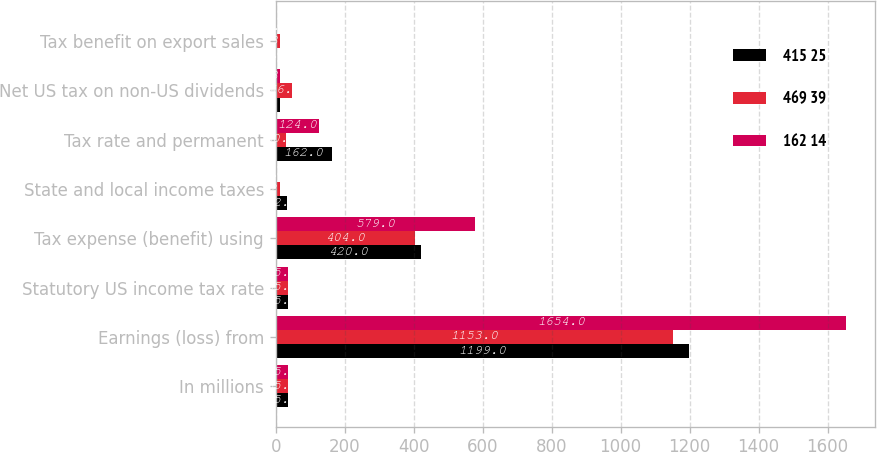Convert chart. <chart><loc_0><loc_0><loc_500><loc_500><stacked_bar_chart><ecel><fcel>In millions<fcel>Earnings (loss) from<fcel>Statutory US income tax rate<fcel>Tax expense (benefit) using<fcel>State and local income taxes<fcel>Tax rate and permanent<fcel>Net US tax on non-US dividends<fcel>Tax benefit on export sales<nl><fcel>415 25<fcel>35<fcel>1199<fcel>35<fcel>420<fcel>32<fcel>162<fcel>11<fcel>2<nl><fcel>469 39<fcel>35<fcel>1153<fcel>35<fcel>404<fcel>12<fcel>30<fcel>46<fcel>13<nl><fcel>162 14<fcel>35<fcel>1654<fcel>35<fcel>579<fcel>2<fcel>124<fcel>13<fcel>3<nl></chart> 